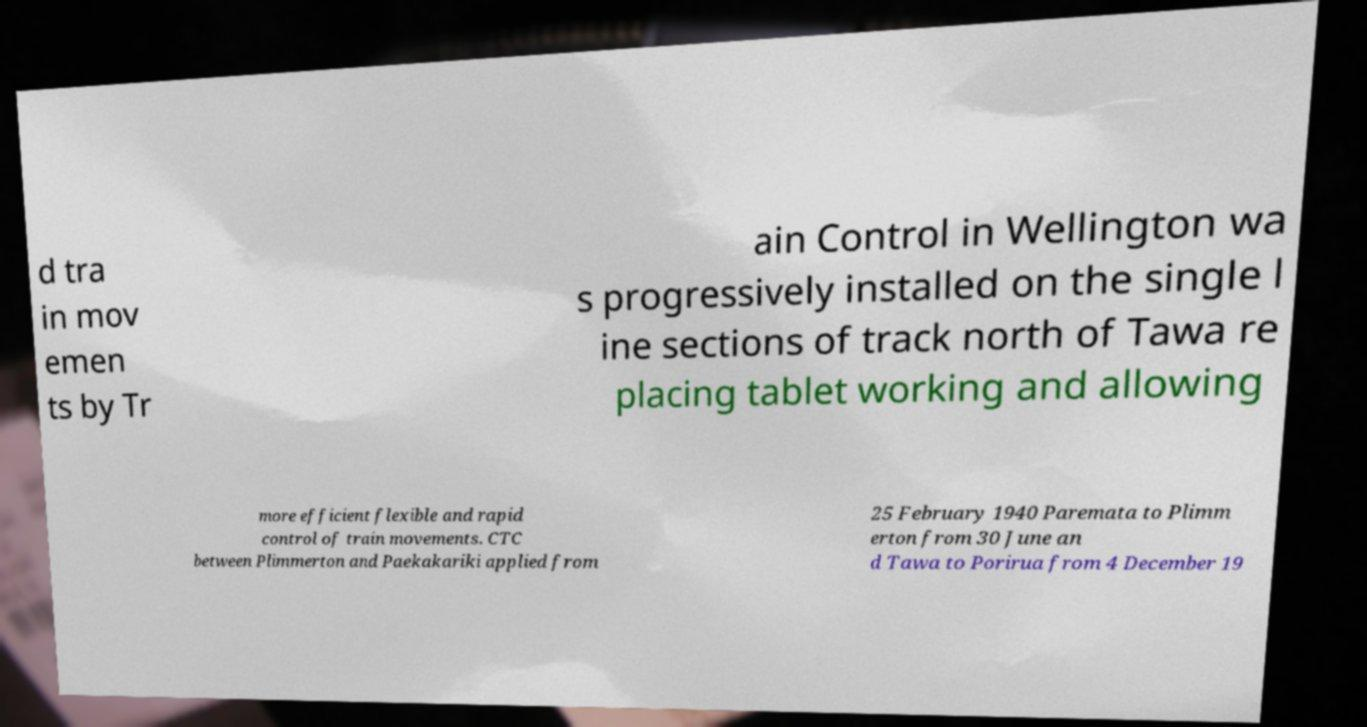For documentation purposes, I need the text within this image transcribed. Could you provide that? d tra in mov emen ts by Tr ain Control in Wellington wa s progressively installed on the single l ine sections of track north of Tawa re placing tablet working and allowing more efficient flexible and rapid control of train movements. CTC between Plimmerton and Paekakariki applied from 25 February 1940 Paremata to Plimm erton from 30 June an d Tawa to Porirua from 4 December 19 